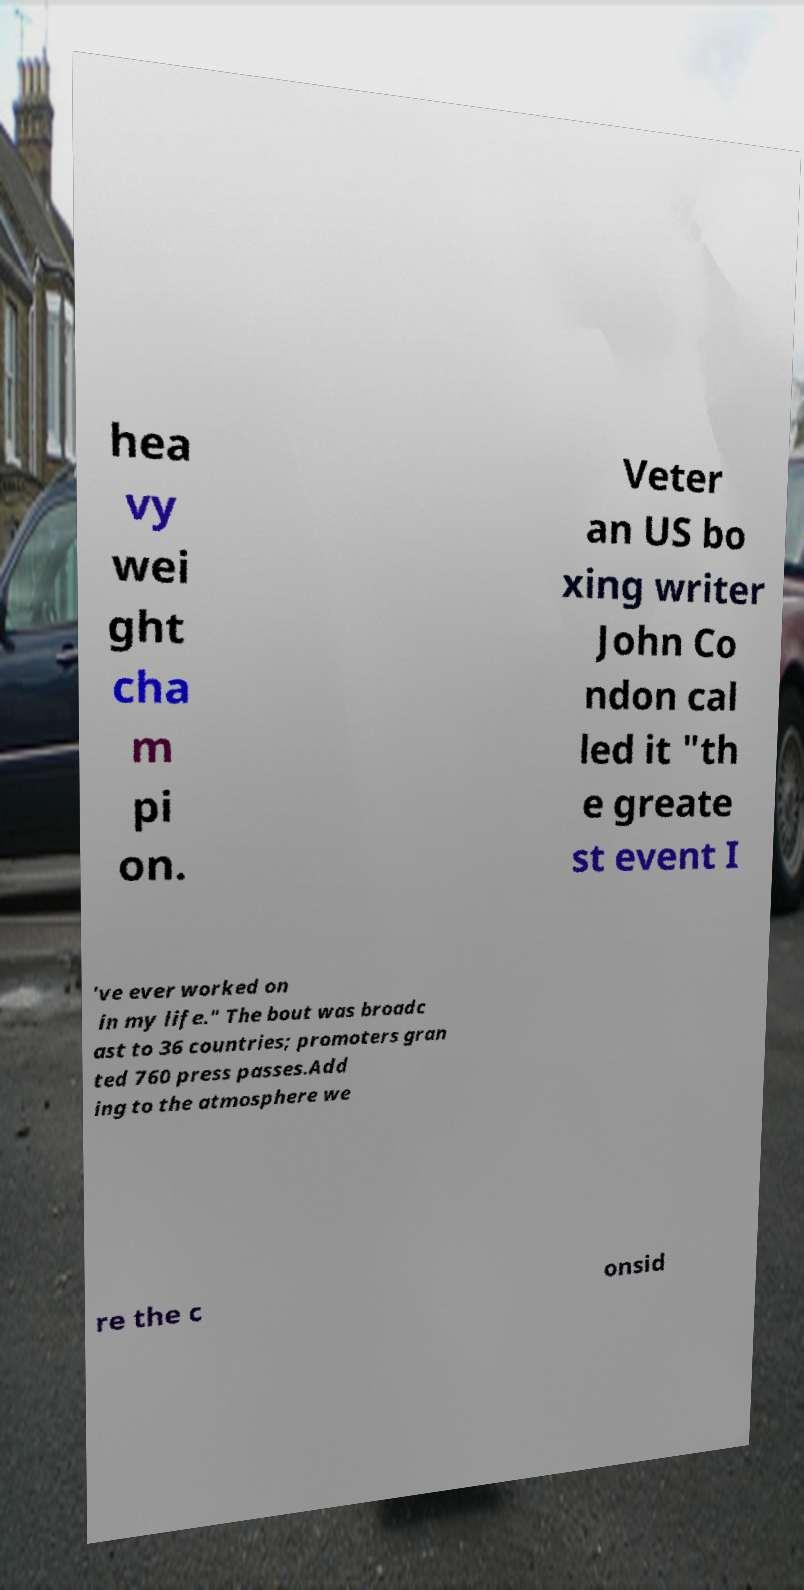For documentation purposes, I need the text within this image transcribed. Could you provide that? hea vy wei ght cha m pi on. Veter an US bo xing writer John Co ndon cal led it "th e greate st event I 've ever worked on in my life." The bout was broadc ast to 36 countries; promoters gran ted 760 press passes.Add ing to the atmosphere we re the c onsid 